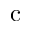<formula> <loc_0><loc_0><loc_500><loc_500>c</formula> 